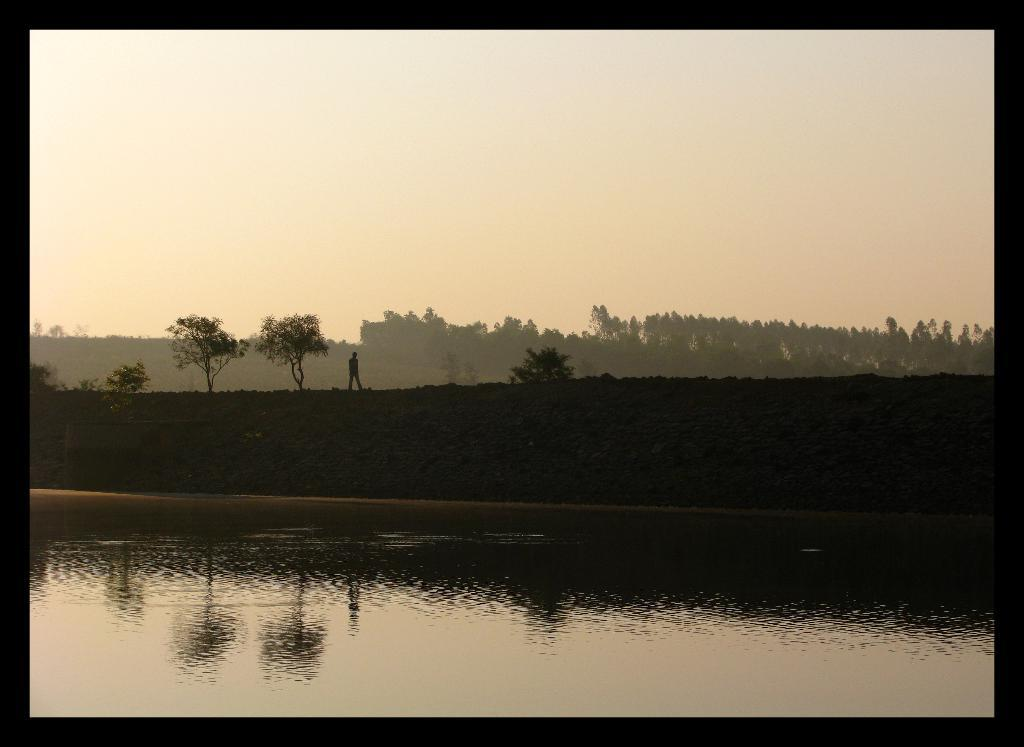What is the primary element present in the image? There is water in the image. What other objects can be seen in the image? There are stones and a person standing in the image. What can be seen in the background of the image? There are trees and the sky visible in the background of the image. How many sticks are being used by the person in the image? There are no sticks present in the image; the person is not holding or using any sticks. 